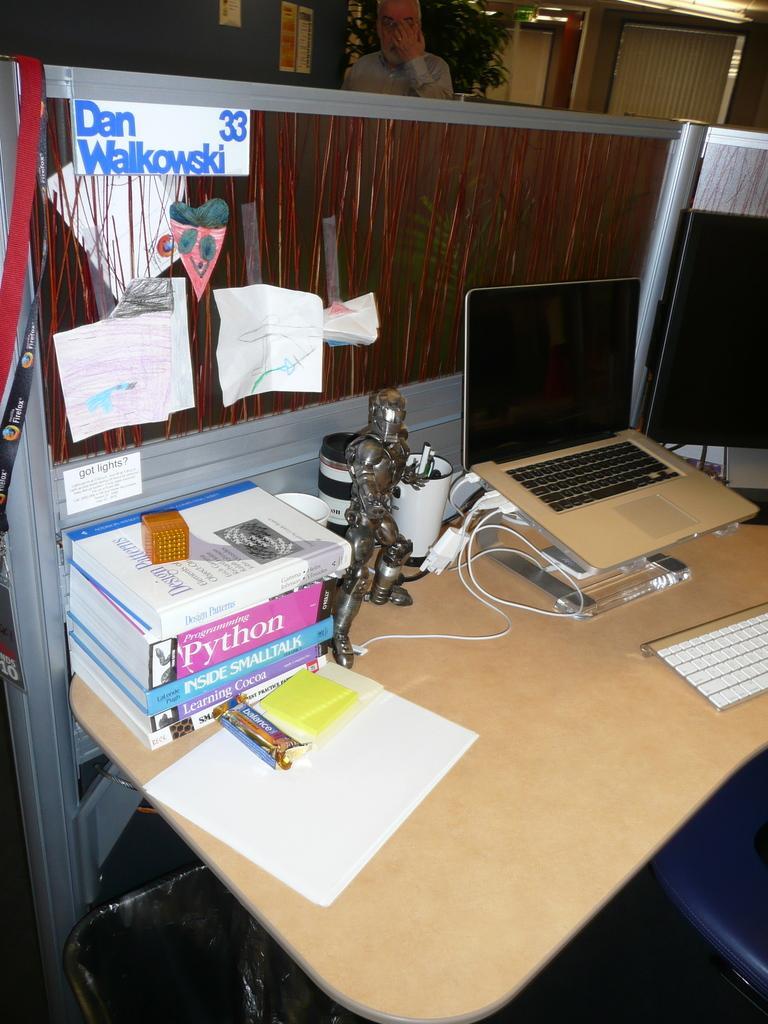Can you describe this image briefly? In this image I see a desk on which there are few papers, books, wire, a toy and a laptop. In the background I see a plant and a person. 